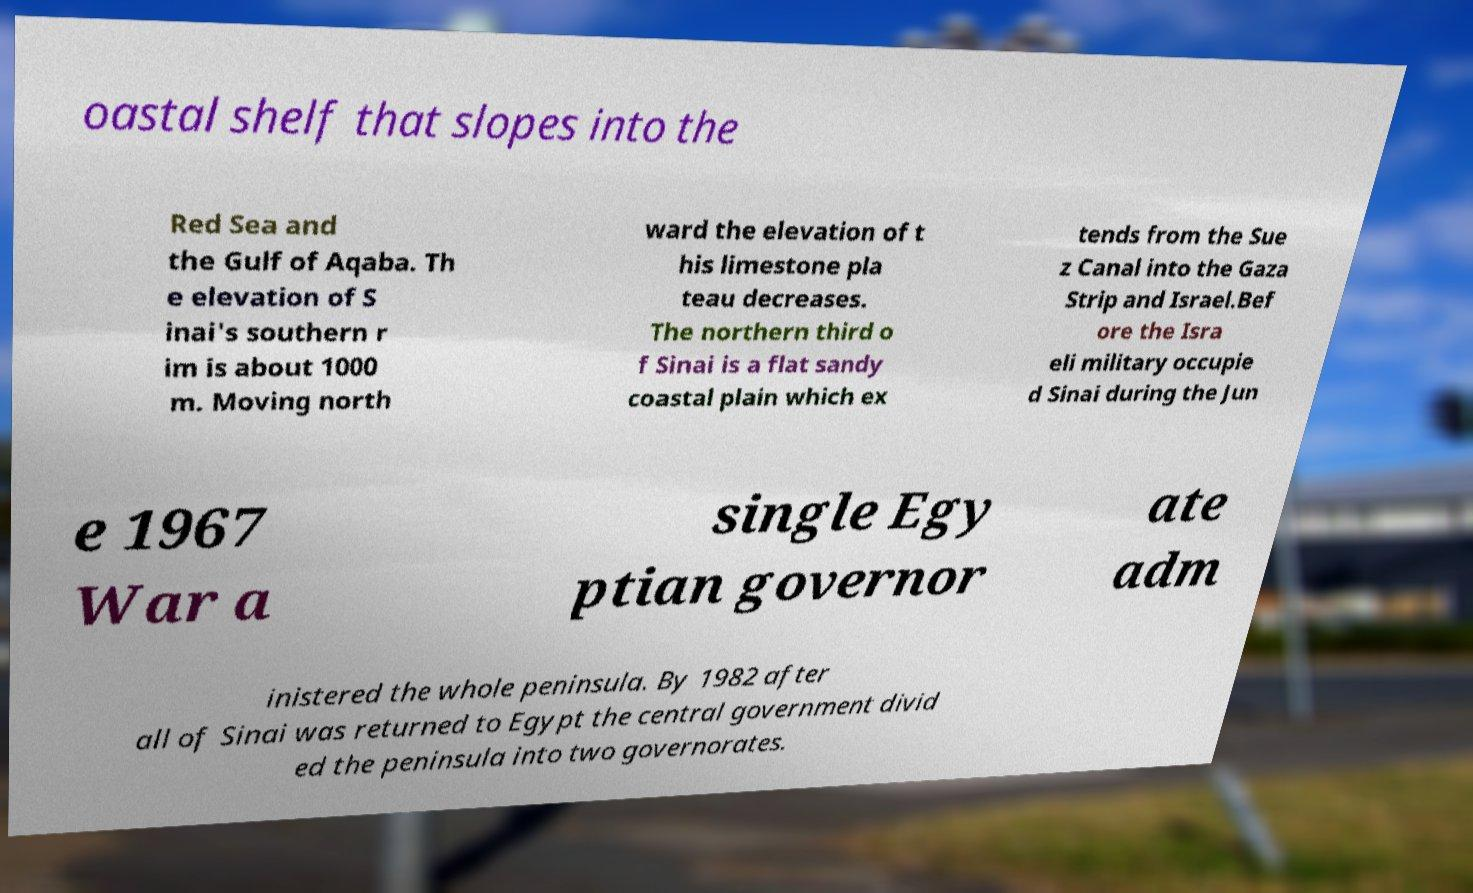Can you read and provide the text displayed in the image?This photo seems to have some interesting text. Can you extract and type it out for me? oastal shelf that slopes into the Red Sea and the Gulf of Aqaba. Th e elevation of S inai's southern r im is about 1000 m. Moving north ward the elevation of t his limestone pla teau decreases. The northern third o f Sinai is a flat sandy coastal plain which ex tends from the Sue z Canal into the Gaza Strip and Israel.Bef ore the Isra eli military occupie d Sinai during the Jun e 1967 War a single Egy ptian governor ate adm inistered the whole peninsula. By 1982 after all of Sinai was returned to Egypt the central government divid ed the peninsula into two governorates. 